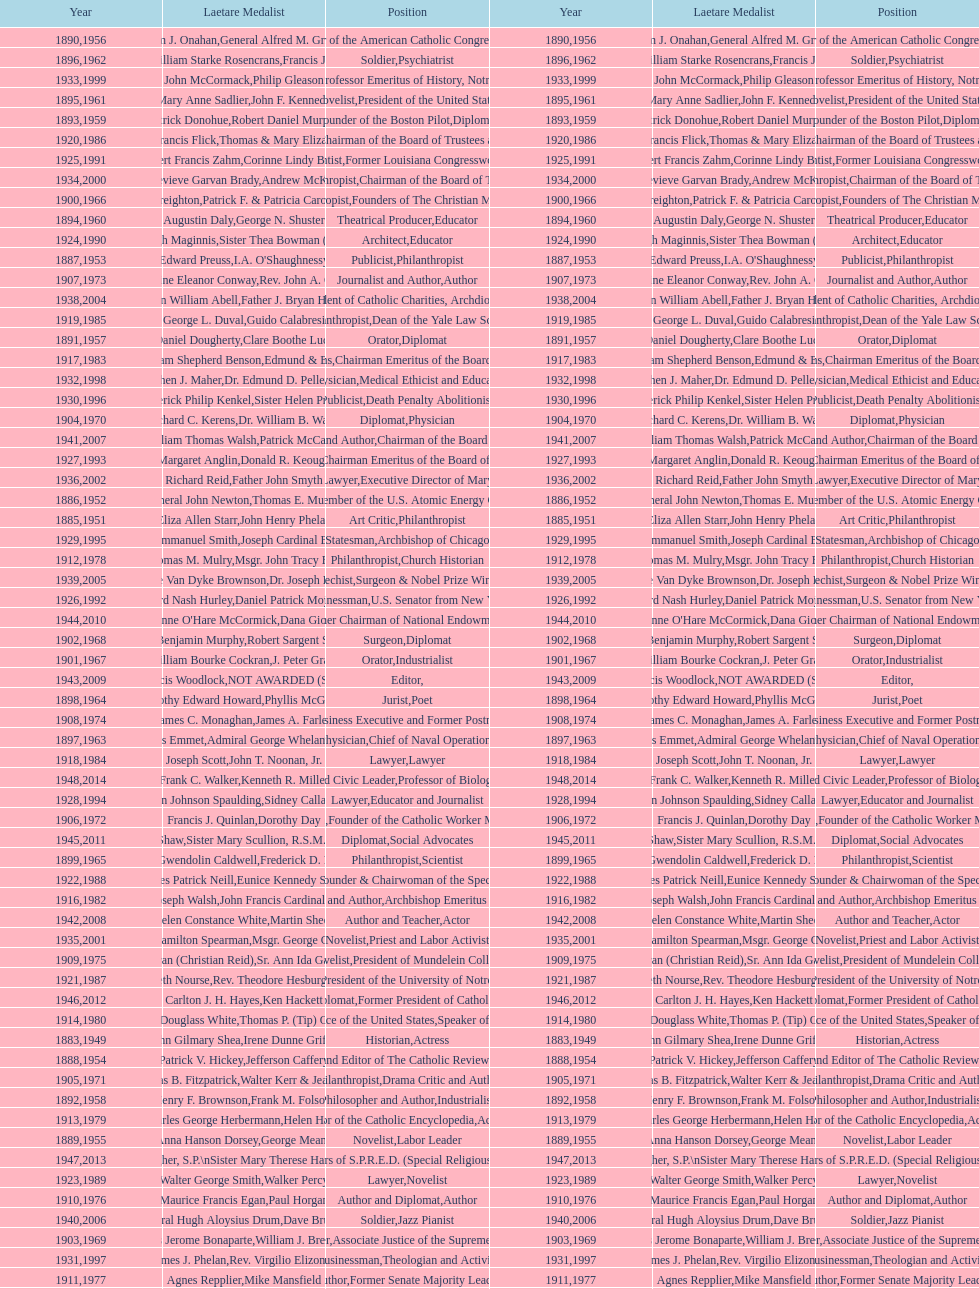How many lawyers have won the award between 1883 and 2014? 5. Help me parse the entirety of this table. {'header': ['Year', 'Laetare Medalist', 'Position', 'Year', 'Laetare Medalist', 'Position'], 'rows': [['1890', 'William J. Onahan', 'Organizer of the American Catholic Congress', '1956', 'General Alfred M. Gruenther', 'Soldier'], ['1896', 'General William Starke Rosencrans', 'Soldier', '1962', 'Francis J. Braceland', 'Psychiatrist'], ['1933', 'John McCormack', 'Artist', '1999', 'Philip Gleason', 'Professor Emeritus of History, Notre Dame'], ['1895', 'Mary Anne Sadlier', 'Novelist', '1961', 'John F. Kennedy', 'President of the United States'], ['1893', 'Patrick Donohue', 'Founder of the Boston Pilot', '1959', 'Robert Daniel Murphy', 'Diplomat'], ['1920', 'Lawrence Francis Flick', 'Physician', '1986', 'Thomas & Mary Elizabeth Carney', 'Chairman of the Board of Trustees and his wife'], ['1925', 'Albert Francis Zahm', 'Scientist', '1991', 'Corinne Lindy Boggs', 'Former Louisiana Congresswoman'], ['1934', 'Genevieve Garvan Brady', 'Philanthropist', '2000', 'Andrew McKenna', 'Chairman of the Board of Trustees'], ['1900', 'John A. Creighton', 'Philanthropist', '1966', 'Patrick F. & Patricia Caron Crowley', 'Founders of The Christian Movement'], ['1894', 'Augustin Daly', 'Theatrical Producer', '1960', 'George N. Shuster', 'Educator'], ['1924', 'Charles Donagh Maginnis', 'Architect', '1990', 'Sister Thea Bowman (posthumously)', 'Educator'], ['1887', 'Edward Preuss', 'Publicist', '1953', "I.A. O'Shaughnessy", 'Philanthropist'], ['1907', 'Katherine Eleanor Conway', 'Journalist and Author', '1973', "Rev. John A. O'Brien", 'Author'], ['1938', 'Irvin William Abell', 'Surgeon', '2004', 'Father J. Bryan Hehir', 'President of Catholic Charities, Archdiocese of Boston'], ['1919', 'George L. Duval', 'Philanthropist', '1985', 'Guido Calabresi', 'Dean of the Yale Law School'], ['1891', 'Daniel Dougherty', 'Orator', '1957', 'Clare Boothe Luce', 'Diplomat'], ['1917', 'Admiral William Shepherd Benson', 'Chief of Naval Operations', '1983', 'Edmund & Evelyn Stephan', 'Chairman Emeritus of the Board of Trustees and his wife'], ['1932', 'Stephen J. Maher', 'Physician', '1998', 'Dr. Edmund D. Pellegrino', 'Medical Ethicist and Educator'], ['1930', 'Frederick Philip Kenkel', 'Publicist', '1996', 'Sister Helen Prejean', 'Death Penalty Abolitionist'], ['1904', 'Richard C. Kerens', 'Diplomat', '1970', 'Dr. William B. Walsh', 'Physician'], ['1941', 'William Thomas Walsh', 'Journalist and Author', '2007', 'Patrick McCartan', 'Chairman of the Board of Trustees'], ['1927', 'Margaret Anglin', 'Actress', '1993', 'Donald R. Keough', 'Chairman Emeritus of the Board of Trustees'], ['1936', 'Richard Reid', 'Journalist and Lawyer', '2002', 'Father John Smyth', 'Executive Director of Maryville Academy'], ['1886', 'General John Newton', 'Engineer', '1952', 'Thomas E. Murray', 'Member of the U.S. Atomic Energy Commission'], ['1885', 'Eliza Allen Starr', 'Art Critic', '1951', 'John Henry Phelan', 'Philanthropist'], ['1929', 'Alfred Emmanuel Smith', 'Statesman', '1995', 'Joseph Cardinal Bernardin', 'Archbishop of Chicago'], ['1912', 'Thomas M. Mulry', 'Philanthropist', '1978', 'Msgr. John Tracy Ellis', 'Church Historian'], ['1939', 'Josephine Van Dyke Brownson', 'Catechist', '2005', 'Dr. Joseph E. Murray', 'Surgeon & Nobel Prize Winner'], ['1926', 'Edward Nash Hurley', 'Businessman', '1992', 'Daniel Patrick Moynihan', 'U.S. Senator from New York'], ['1944', "Anne O'Hare McCormick", 'Journalist', '2010', 'Dana Gioia', 'Former Chairman of National Endowment for the Arts'], ['1902', 'John Benjamin Murphy', 'Surgeon', '1968', 'Robert Sargent Shriver', 'Diplomat'], ['1901', 'William Bourke Cockran', 'Orator', '1967', 'J. Peter Grace', 'Industrialist'], ['1943', 'Thomas Francis Woodlock', 'Editor', '2009', 'NOT AWARDED (SEE BELOW)', ''], ['1898', 'Timothy Edward Howard', 'Jurist', '1964', 'Phyllis McGinley', 'Poet'], ['1908', 'James C. Monaghan', 'Economist', '1974', 'James A. Farley', 'Business Executive and Former Postmaster General'], ['1897', 'Thomas Addis Emmet', 'Physician', '1963', 'Admiral George Whelan Anderson, Jr.', 'Chief of Naval Operations'], ['1918', 'Joseph Scott', 'Lawyer', '1984', 'John T. Noonan, Jr.', 'Lawyer'], ['1948', 'Frank C. Walker', 'Postmaster General and Civic Leader', '2014', 'Kenneth R. Miller', 'Professor of Biology at Brown University'], ['1928', 'John Johnson Spaulding', 'Lawyer', '1994', 'Sidney Callahan', 'Educator and Journalist'], ['1906', 'Francis J. Quinlan', 'Physician', '1972', 'Dorothy Day', 'Founder of the Catholic Worker Movement'], ['1945', 'Gardiner Howland Shaw', 'Diplomat', '2011', 'Sister Mary Scullion, R.S.M., & Joan McConnon', 'Social Advocates'], ['1899', 'Mary Gwendolin Caldwell', 'Philanthropist', '1965', 'Frederick D. Rossini', 'Scientist'], ['1922', 'Charles Patrick Neill', 'Economist', '1988', 'Eunice Kennedy Shriver', 'Founder & Chairwoman of the Special Olympics'], ['1916', 'James Joseph Walsh', 'Physician and Author', '1982', 'John Francis Cardinal Dearden', 'Archbishop Emeritus of Detroit'], ['1942', 'Helen Constance White', 'Author and Teacher', '2008', 'Martin Sheen', 'Actor'], ['1935', 'Francis Hamilton Spearman', 'Novelist', '2001', 'Msgr. George G. Higgins', 'Priest and Labor Activist'], ['1909', 'Frances Tieran (Christian Reid)', 'Novelist', '1975', 'Sr. Ann Ida Gannon, BMV', 'President of Mundelein College'], ['1921', 'Elizabeth Nourse', 'Artist', '1987', 'Rev. Theodore Hesburgh, CSC', 'President of the University of Notre Dame'], ['1946', 'Carlton J. H. Hayes', 'Historian and Diplomat', '2012', 'Ken Hackett', 'Former President of Catholic Relief Services'], ['1914', 'Edward Douglass White', 'Chief Justice of the United States', '1980', "Thomas P. (Tip) O'Neill Jr.", 'Speaker of the House'], ['1883', 'John Gilmary Shea', 'Historian', '1949', 'Irene Dunne Griffin', 'Actress'], ['1888', 'Patrick V. Hickey', 'Founder and Editor of The Catholic Review', '1954', 'Jefferson Caffery', 'Diplomat'], ['1905', 'Thomas B. Fitzpatrick', 'Philanthropist', '1971', 'Walter Kerr & Jean Kerr', 'Drama Critic and Author'], ['1892', 'Henry F. Brownson', 'Philosopher and Author', '1958', 'Frank M. Folsom', 'Industrialist'], ['1913', 'Charles George Herbermann', 'Editor of the Catholic Encyclopedia', '1979', 'Helen Hayes', 'Actress'], ['1889', 'Anna Hanson Dorsey', 'Novelist', '1955', 'George Meany', 'Labor Leader'], ['1947', 'William G. Bruce', 'Publisher and Civic Leader', '2013', 'Sister Susanne Gallagher, S.P.\\nSister Mary Therese Harrington, S.H.\\nRev. James H. McCarthy', 'Founders of S.P.R.E.D. (Special Religious Education Development Network)'], ['1923', 'Walter George Smith', 'Lawyer', '1989', 'Walker Percy', 'Novelist'], ['1910', 'Maurice Francis Egan', 'Author and Diplomat', '1976', 'Paul Horgan', 'Author'], ['1940', 'General Hugh Aloysius Drum', 'Soldier', '2006', 'Dave Brubeck', 'Jazz Pianist'], ['1903', 'Charles Jerome Bonaparte', 'Lawyer', '1969', 'William J. Brennan Jr.', 'Associate Justice of the Supreme Court'], ['1931', 'James J. Phelan', 'Businessman', '1997', 'Rev. Virgilio Elizondo', 'Theologian and Activist'], ['1911', 'Agnes Repplier', 'Author', '1977', 'Mike Mansfield', 'Former Senate Majority Leader'], ['1884', 'Patrick Charles Keely', 'Architect', '1950', 'General Joseph L. Collins', 'Soldier'], ['1915', 'Mary V. Merrick', 'Philanthropist', '1981', 'Edmund Sixtus Muskie', 'Secretary of State'], ['1937', 'Jeremiah D. M. Ford', 'Scholar', '2003', "Peter and Margaret O'Brien Steinfels", 'Editors of Commonweal']]} 